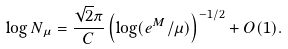Convert formula to latex. <formula><loc_0><loc_0><loc_500><loc_500>\log N _ { \mu } = \frac { \sqrt { 2 } \pi } { C } \left ( \log ( e ^ { M } / \mu ) \right ) ^ { - 1 / 2 } + O ( 1 ) .</formula> 